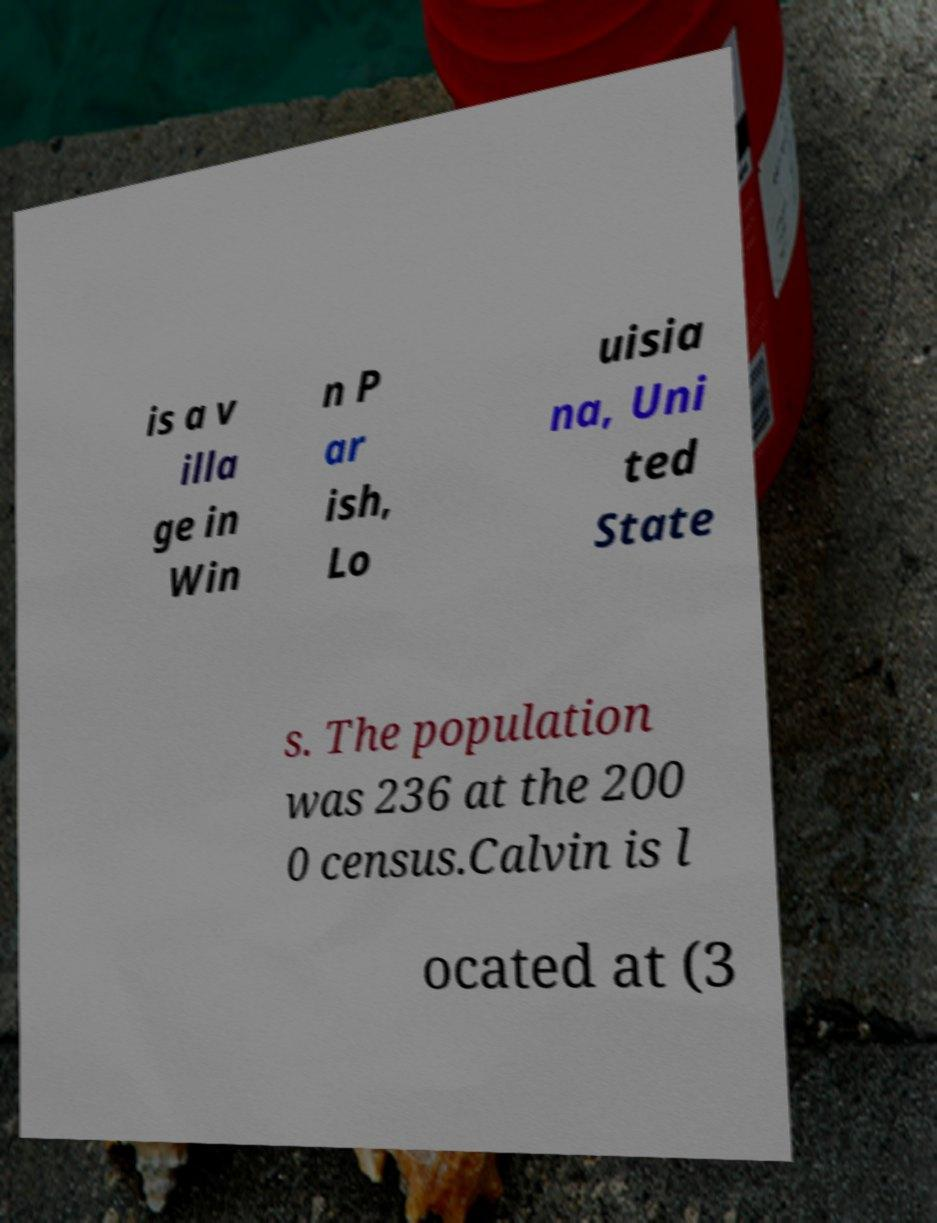Can you read and provide the text displayed in the image?This photo seems to have some interesting text. Can you extract and type it out for me? is a v illa ge in Win n P ar ish, Lo uisia na, Uni ted State s. The population was 236 at the 200 0 census.Calvin is l ocated at (3 